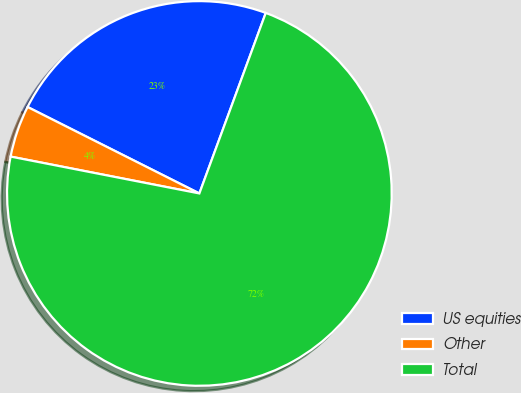Convert chart to OTSL. <chart><loc_0><loc_0><loc_500><loc_500><pie_chart><fcel>US equities<fcel>Other<fcel>Total<nl><fcel>23.19%<fcel>4.35%<fcel>72.46%<nl></chart> 